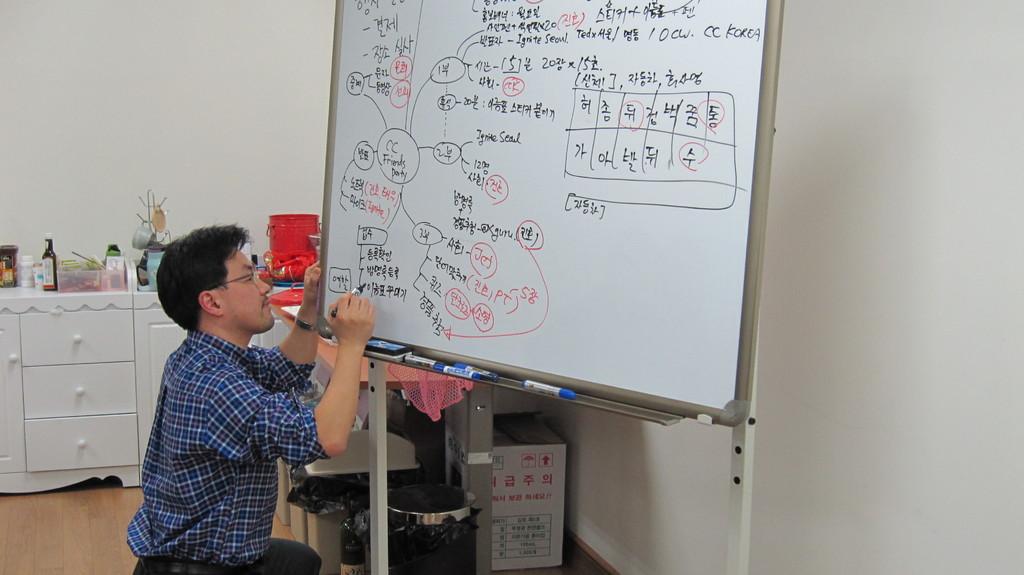Is the language written on the board english?
Give a very brief answer. No. 